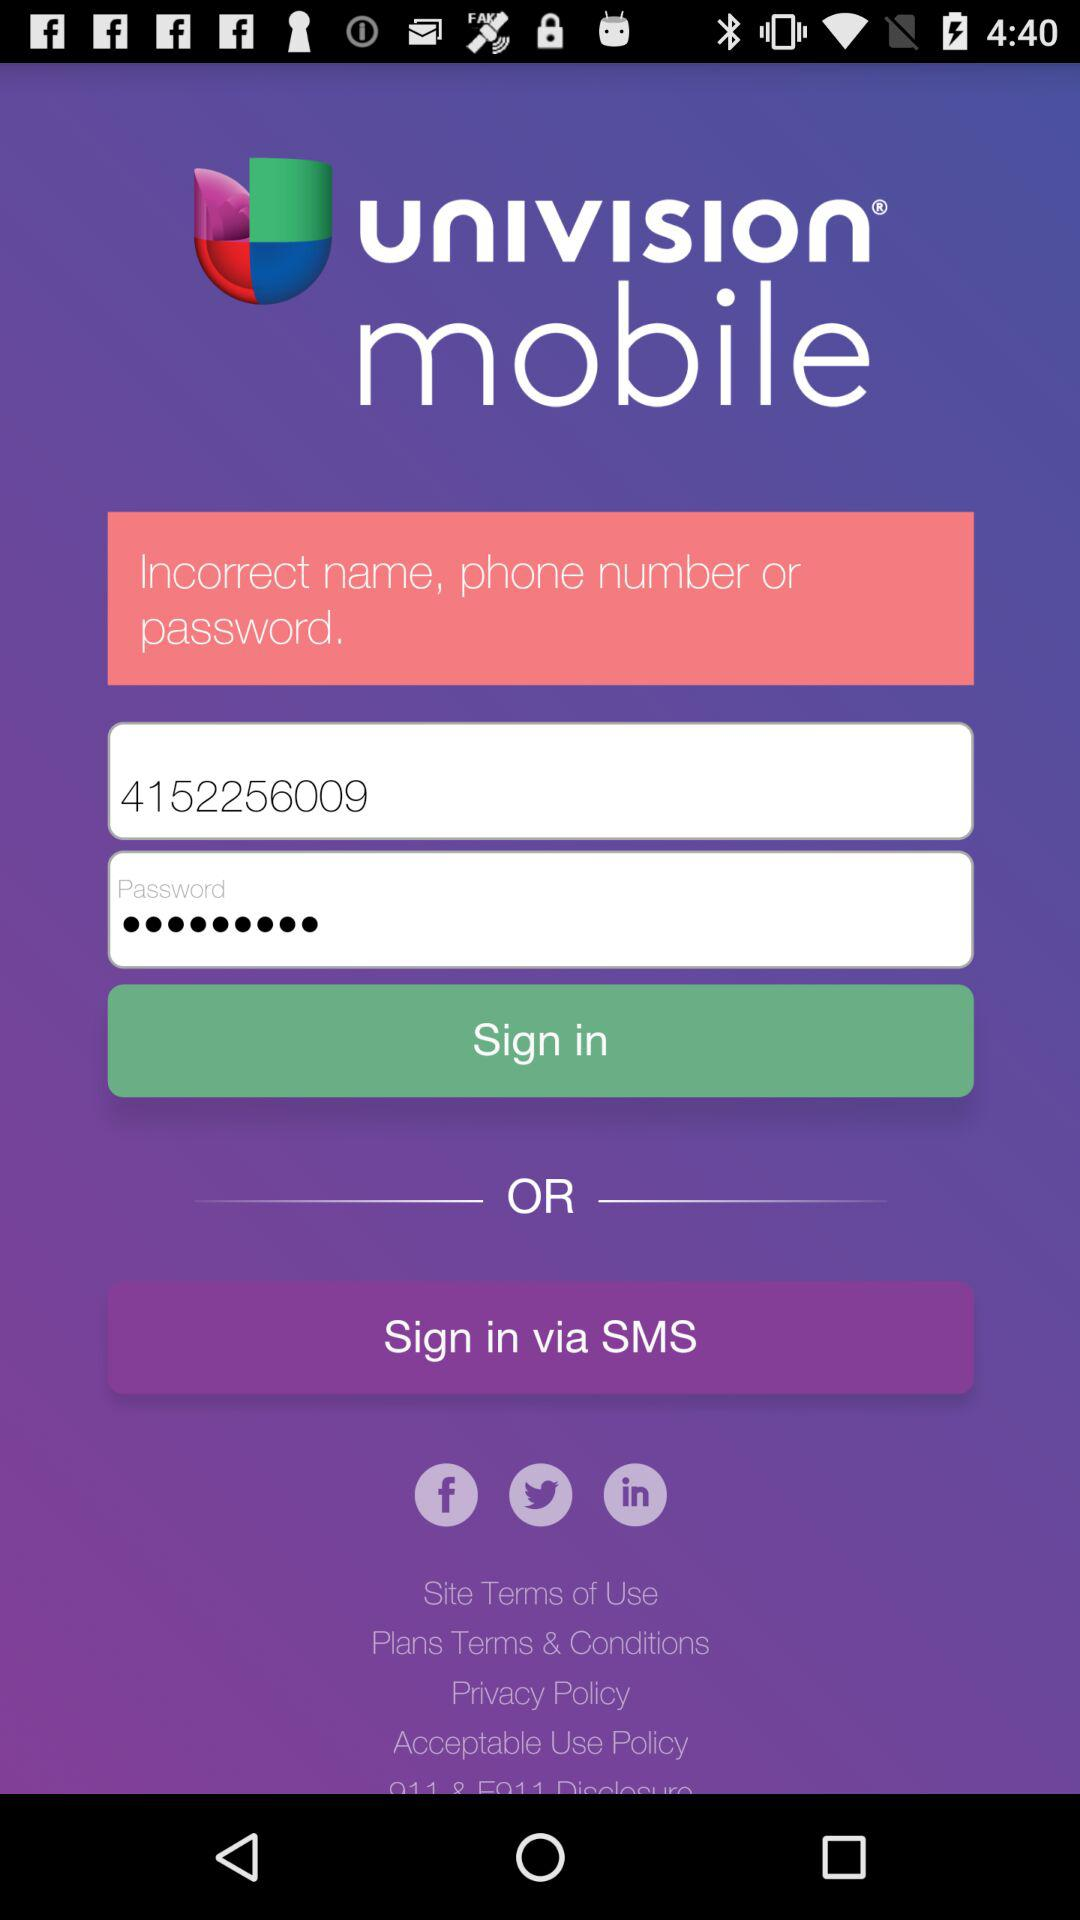What is the phone number? The phone number is 4152256009. 